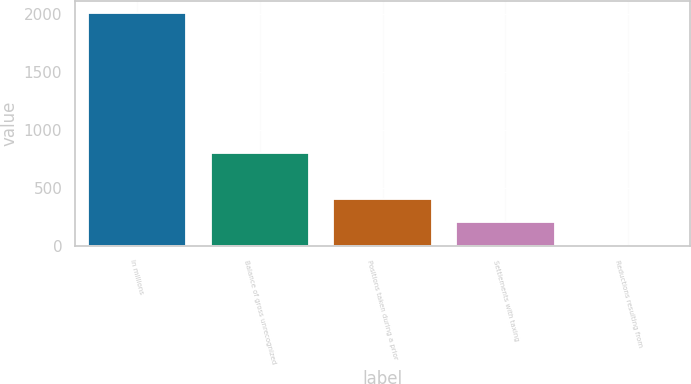<chart> <loc_0><loc_0><loc_500><loc_500><bar_chart><fcel>In millions<fcel>Balance of gross unrecognized<fcel>Positions taken during a prior<fcel>Settlements with taxing<fcel>Reductions resulting from<nl><fcel>2010<fcel>805.8<fcel>404.4<fcel>203.7<fcel>3<nl></chart> 